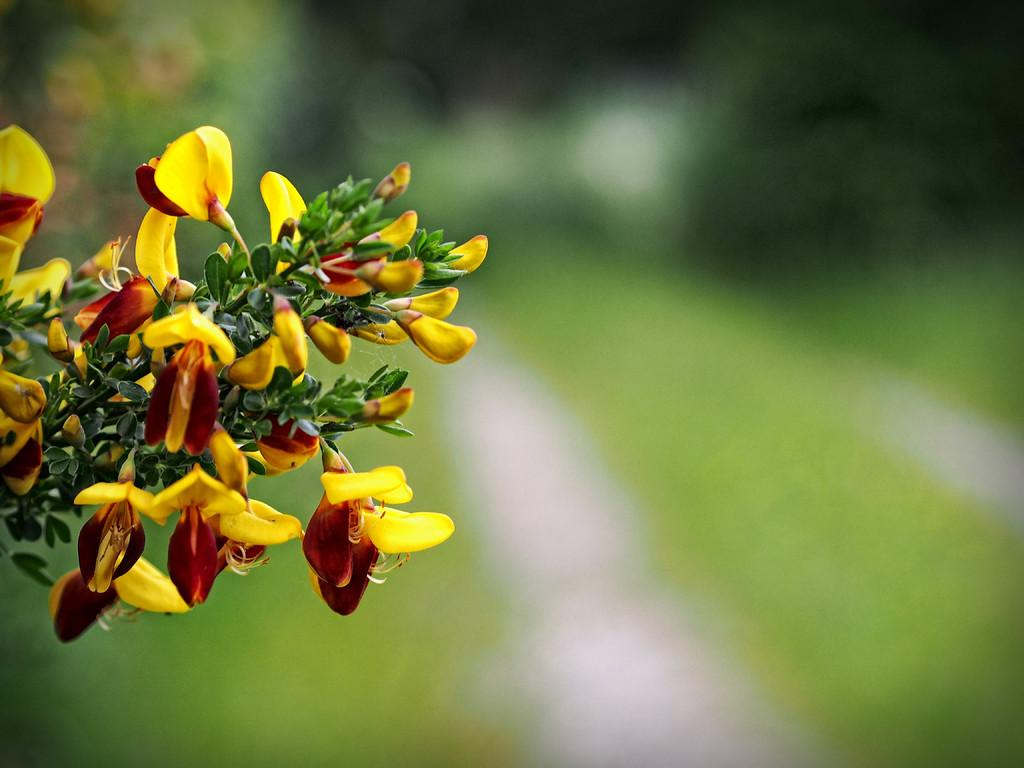What is the main subject of the image? The main subject of the image is a stem of a plant. What can be seen on the stem of the plant? There are flowers and leaves on the stem of the plant. What type of fan is visible in the image? There is no fan present in the image; it features a stem of a plant with flowers and leaves. How many eggs are visible on the stem of the plant in the image? There are no eggs present on the stem of the plant in the image. 